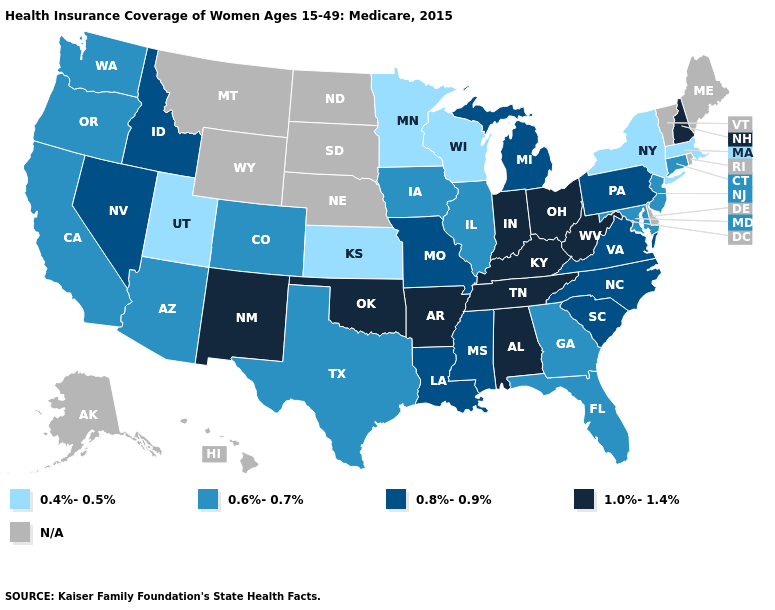Name the states that have a value in the range 0.8%-0.9%?
Concise answer only. Idaho, Louisiana, Michigan, Mississippi, Missouri, Nevada, North Carolina, Pennsylvania, South Carolina, Virginia. What is the value of Maryland?
Concise answer only. 0.6%-0.7%. What is the value of Montana?
Answer briefly. N/A. Among the states that border California , which have the highest value?
Give a very brief answer. Nevada. Does New Mexico have the highest value in the West?
Short answer required. Yes. How many symbols are there in the legend?
Concise answer only. 5. What is the value of South Dakota?
Be succinct. N/A. Which states have the highest value in the USA?
Give a very brief answer. Alabama, Arkansas, Indiana, Kentucky, New Hampshire, New Mexico, Ohio, Oklahoma, Tennessee, West Virginia. Which states have the lowest value in the MidWest?
Give a very brief answer. Kansas, Minnesota, Wisconsin. What is the value of Arizona?
Quick response, please. 0.6%-0.7%. Does the map have missing data?
Keep it brief. Yes. What is the highest value in the West ?
Keep it brief. 1.0%-1.4%. What is the value of Colorado?
Answer briefly. 0.6%-0.7%. Name the states that have a value in the range 0.8%-0.9%?
Write a very short answer. Idaho, Louisiana, Michigan, Mississippi, Missouri, Nevada, North Carolina, Pennsylvania, South Carolina, Virginia. 